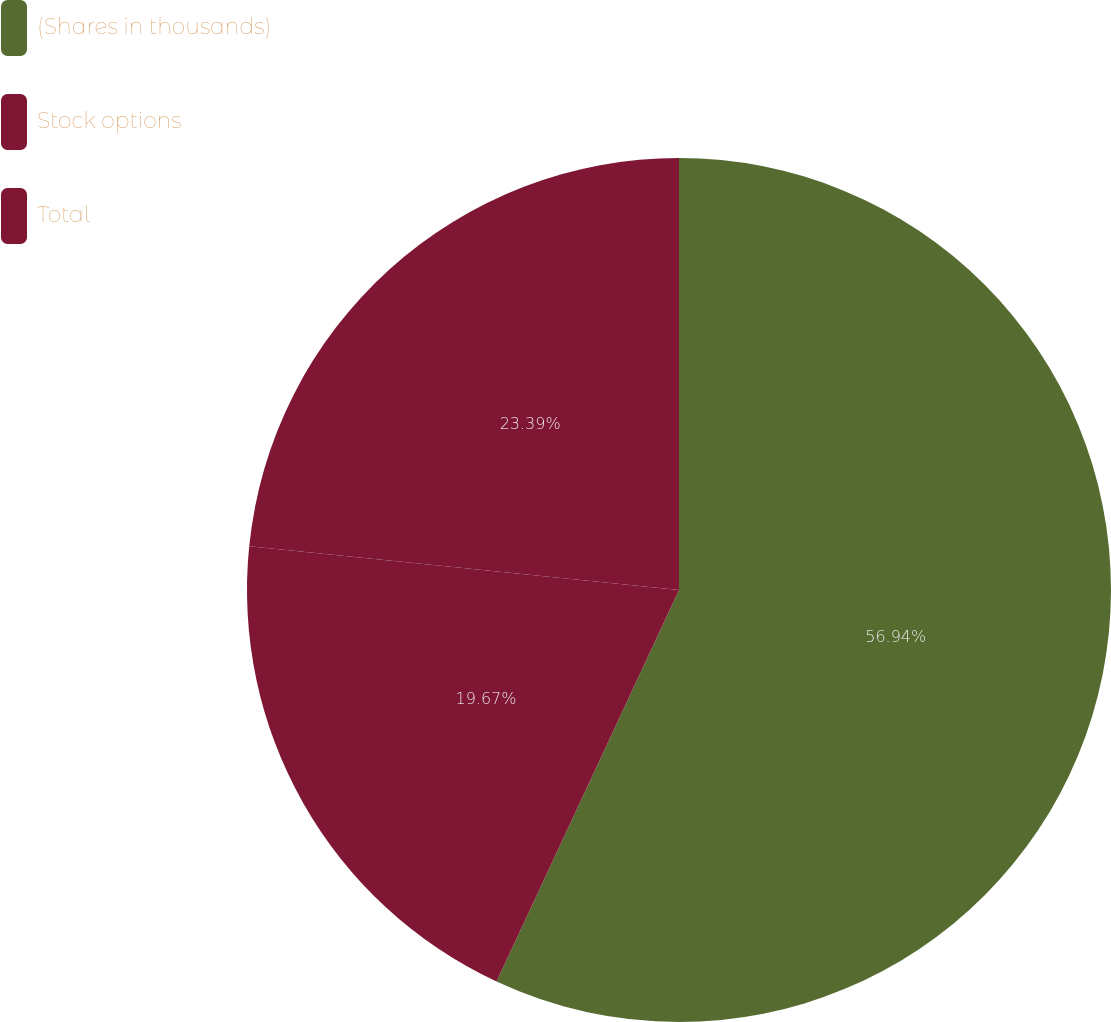<chart> <loc_0><loc_0><loc_500><loc_500><pie_chart><fcel>(Shares in thousands)<fcel>Stock options<fcel>Total<nl><fcel>56.94%<fcel>19.67%<fcel>23.39%<nl></chart> 